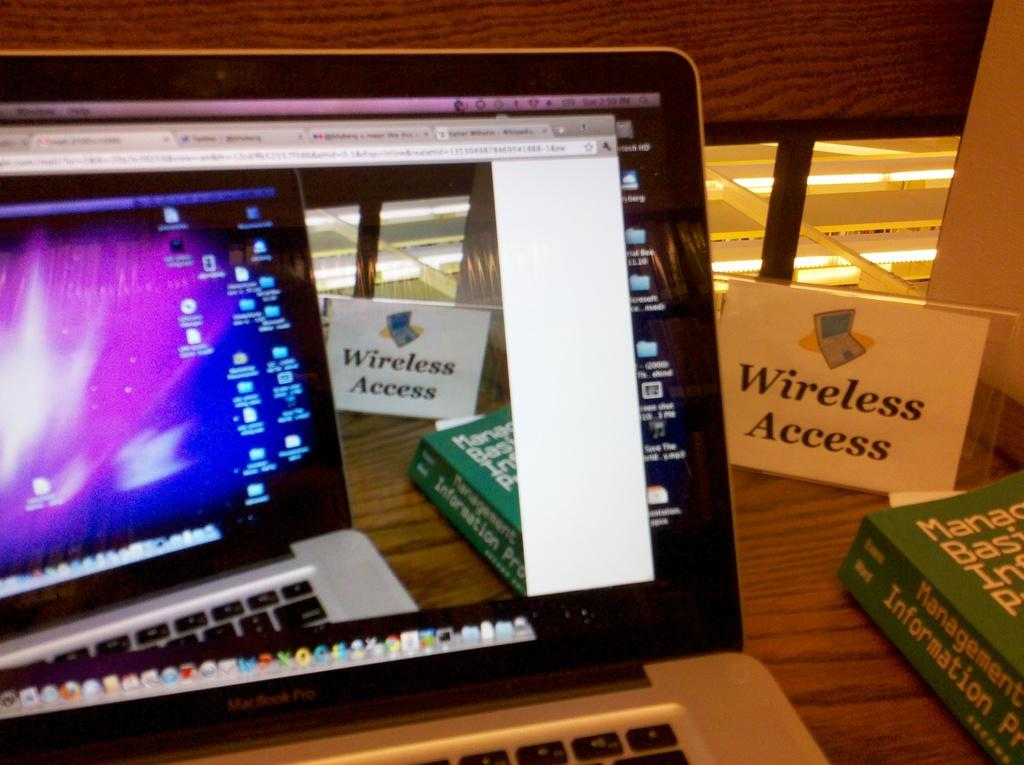<image>
Provide a brief description of the given image. The card behind the computer called wireless access 